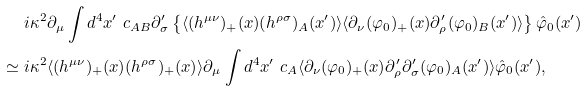<formula> <loc_0><loc_0><loc_500><loc_500>& \ i \kappa ^ { 2 } \partial _ { \mu } \int d ^ { 4 } x ^ { \prime } \ c _ { A B } \partial _ { \sigma } ^ { \prime } \left \{ \langle ( h ^ { \mu \nu } ) _ { + } ( x ) ( h ^ { \rho \sigma } ) _ { A } ( x ^ { \prime } ) \rangle \langle \partial _ { \nu } ( \varphi _ { 0 } ) _ { + } ( x ) \partial _ { \rho } ^ { \prime } ( \varphi _ { 0 } ) _ { B } ( x ^ { \prime } ) \rangle \right \} \hat { \varphi } _ { 0 } ( x ^ { \prime } ) \\ \simeq & \ i \kappa ^ { 2 } \langle ( h ^ { \mu \nu } ) _ { + } ( x ) ( h ^ { \rho \sigma } ) _ { + } ( x ) \rangle \partial _ { \mu } \int d ^ { 4 } x ^ { \prime } \ c _ { A } \langle \partial _ { \nu } ( \varphi _ { 0 } ) _ { + } ( x ) \partial _ { \rho } ^ { \prime } \partial _ { \sigma } ^ { \prime } ( \varphi _ { 0 } ) _ { A } ( x ^ { \prime } ) \rangle \hat { \varphi } _ { 0 } ( x ^ { \prime } ) ,</formula> 